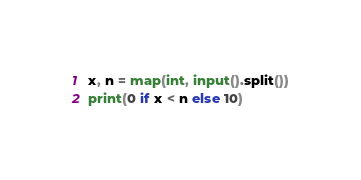Convert code to text. <code><loc_0><loc_0><loc_500><loc_500><_Python_>x, n = map(int, input().split())
print(0 if x < n else 10)
</code> 